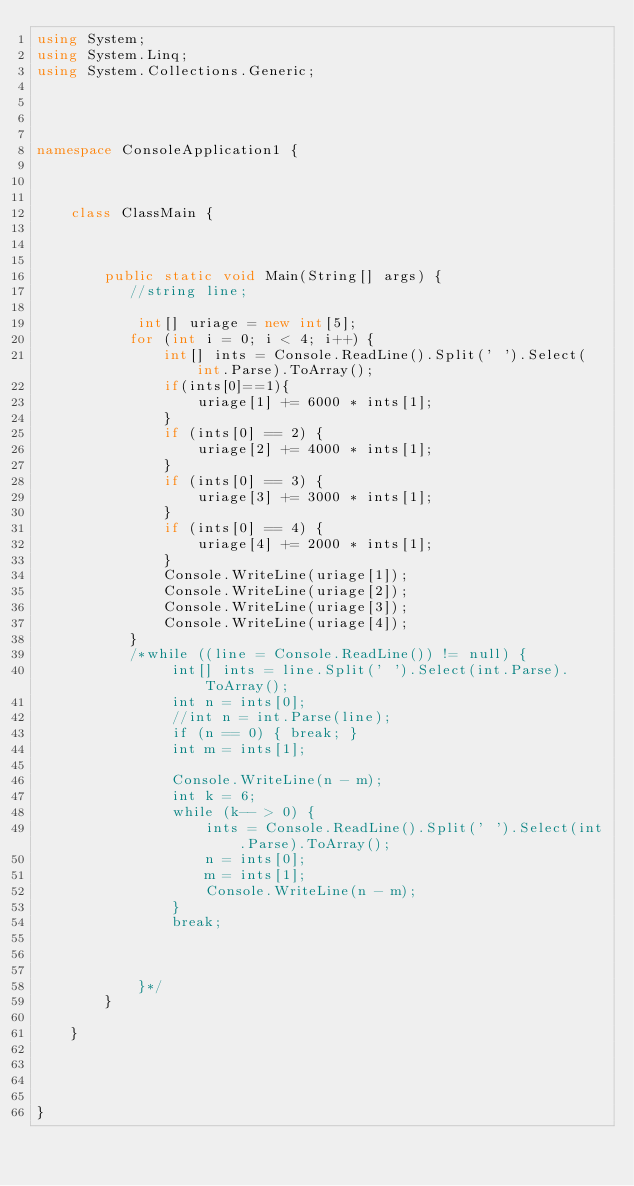<code> <loc_0><loc_0><loc_500><loc_500><_C#_>using System;
using System.Linq;
using System.Collections.Generic;




namespace ConsoleApplication1 {

    

    class ClassMain {



        public static void Main(String[] args) {
           //string line;

            int[] uriage = new int[5];
           for (int i = 0; i < 4; i++) {
               int[] ints = Console.ReadLine().Split(' ').Select(int.Parse).ToArray();
               if(ints[0]==1){
                   uriage[1] += 6000 * ints[1];
               }
               if (ints[0] == 2) {
                   uriage[2] += 4000 * ints[1];
               }
               if (ints[0] == 3) {
                   uriage[3] += 3000 * ints[1];
               }
               if (ints[0] == 4) {
                   uriage[4] += 2000 * ints[1];
               }
               Console.WriteLine(uriage[1]);
               Console.WriteLine(uriage[2]);
               Console.WriteLine(uriage[3]);
               Console.WriteLine(uriage[4]);
           }
           /*while ((line = Console.ReadLine()) != null) {
                int[] ints = line.Split(' ').Select(int.Parse).ToArray();
                int n = ints[0];
                //int n = int.Parse(line);                
                if (n == 0) { break; }
                int m = ints[1];

                Console.WriteLine(n - m);
                int k = 6;
                while (k-- > 0) {
                    ints = Console.ReadLine().Split(' ').Select(int.Parse).ToArray();
                    n = ints[0];
                    m = ints[1];
                    Console.WriteLine(n - m);
                }
                break;
                
 

            }*/
        }

    }

    


}</code> 